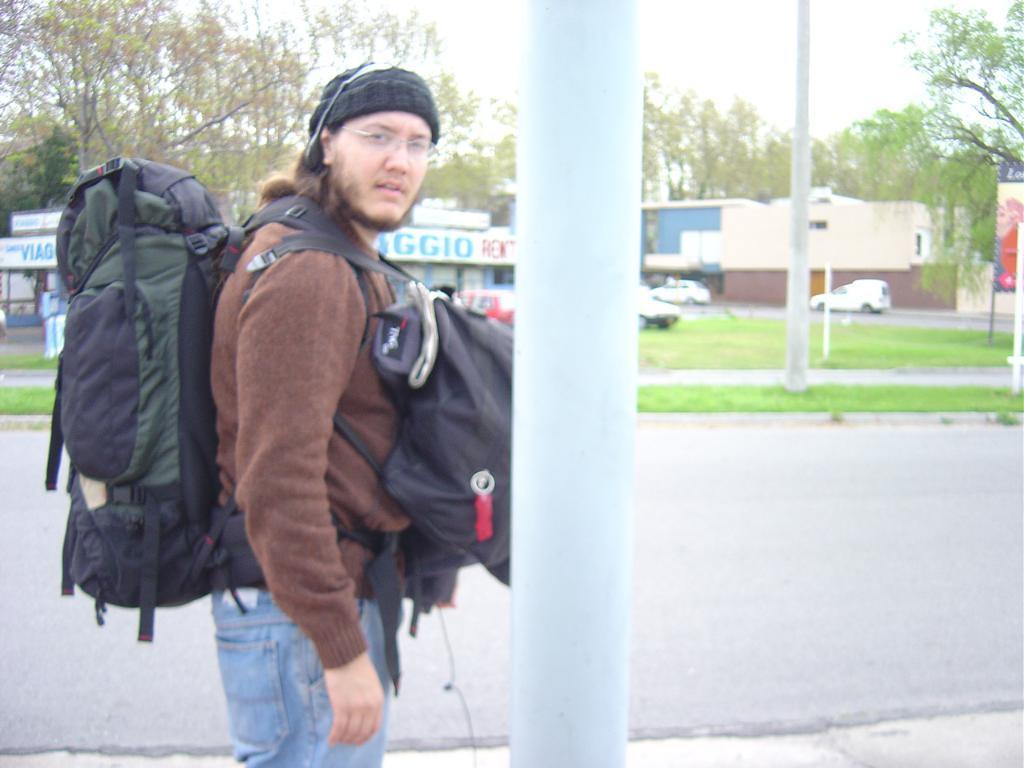Can you describe this image briefly? A person is carrying bags on him in his front and back,standing at the pole. In the background there are trees,sky,pole,vehicles,hoarding and buildings. 